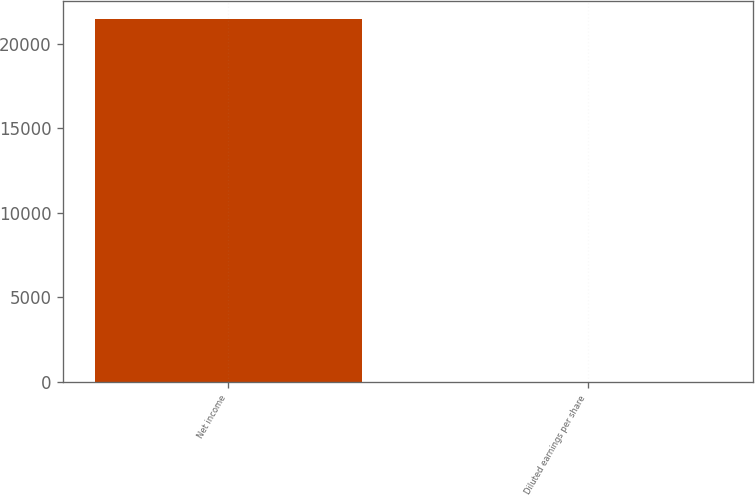Convert chart. <chart><loc_0><loc_0><loc_500><loc_500><bar_chart><fcel>Net income<fcel>Diluted earnings per share<nl><fcel>21446<fcel>0.3<nl></chart> 